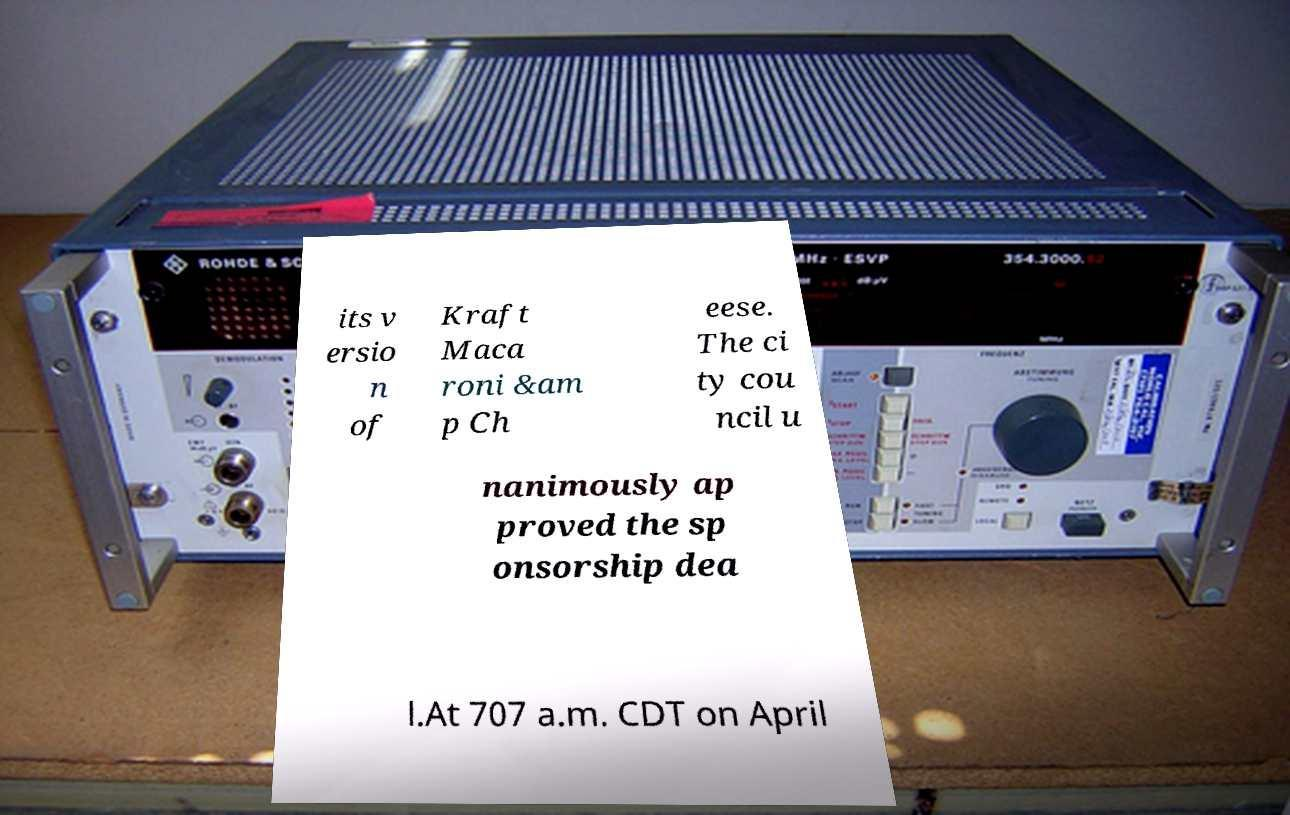Could you assist in decoding the text presented in this image and type it out clearly? its v ersio n of Kraft Maca roni &am p Ch eese. The ci ty cou ncil u nanimously ap proved the sp onsorship dea l.At 707 a.m. CDT on April 